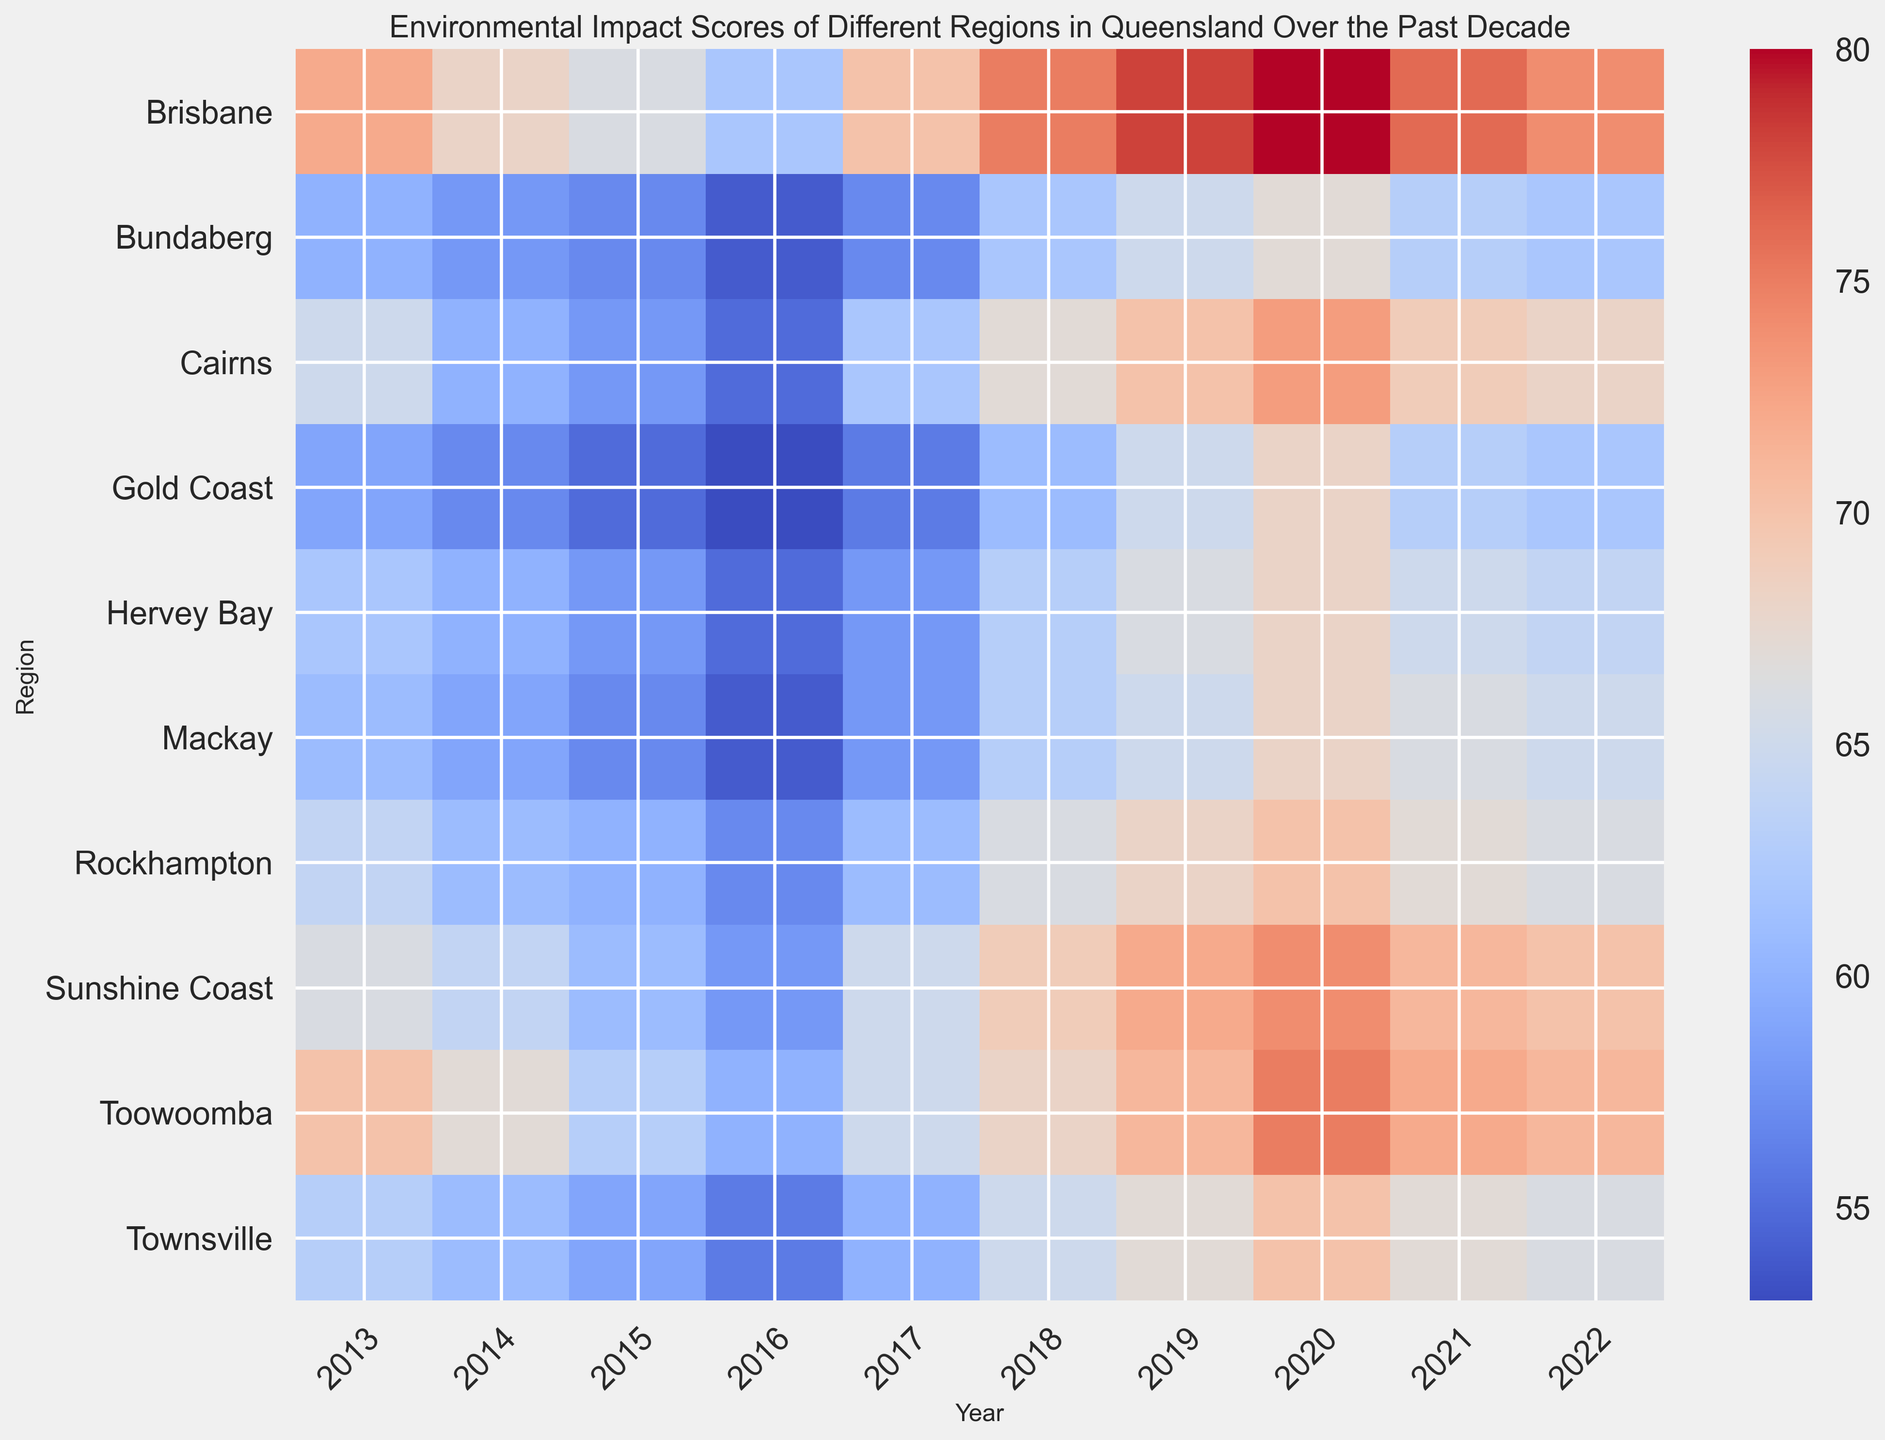Which region has the highest environmental impact score in 2020? To find the highest score for 2020, look at the column for 2020 in the heatmap and identify the region with the darkest red color indicating the highest value. The highest score is in Brisbane.
Answer: Brisbane What is the average environmental impact score for Brisbane over the past decade? Sum the environmental impact scores for Brisbane from 2013 to 2022 and then divide by the number of years (10). (72 + 68 + 66 + 62 + 70 + 75 + 78 + 80 + 76 + 74) / 10 = 72.1
Answer: 72.1 Which year had the lowest environmental impact score for the Gold Coast? To find the lowest score for the Gold Coast, scan the row for Gold Coast and identify the year with the lightest color indicating the lowest value. The lowest score is in 2016.
Answer: 2016 Compare the environmental impact scores of Cairns and Townsville in 2019. Which region had a higher score? Look at the year 2019 for both Cairns and Townsville in the heatmap. Identify the region with the darker color. Cairns has a value of 70 while Townsville has 67, so Cairns had a higher score.
Answer: Cairns What is the difference in the environmental impact scores between Toowoomba and Mackay in 2022? Look at the values for Toowoomba and Mackay in the year 2022 and subtract the score of Mackay from Toowoomba's score. Toowoomba has 71, Mackay has 65, so the difference is 71 - 65 = 6
Answer: 6 What trend can you observe in the environmental impact scores for Hervey Bay from 2013 to 2022? Observe the color changes for Hervey Bay across the decade. The scores start at a lighter color indicating lower values and gradually show darker colors towards the middle of the decade, slightly decreasing again towards 2022, indicating an initial increase followed by a slight decrease.
Answer: Increasing then slightly decreasing If you were to rank the regions by their environmental impact score for the year 2017, what position would Rockhampton hold? List the scores for all regions in 2017 and order from highest to lowest. Rockhampton's score is 61, and only Hervey Bay and Bundaberg have lower scores, placing Rockhampton in the 9th (third from last) position.
Answer: 9th Which region shows the most consistent scores over the decade, indicating the least variability? Observe the color consistency across the rows for each region. Both Toowoomba and Rockhampton show relatively consistent colors (shades of red) with minimal change, suggesting they are the most consistent.
Answer: Toowoomba and Rockhampton How many regions had an environmental impact score above 70 in 2020? Look at the column for the year 2020 and count the number of regions whose color indicates scores above 70. Brisbane, Cairns, Sunshine Coast, and Toowoomba show scores above 70, thus 4 regions in total.
Answer: 4 